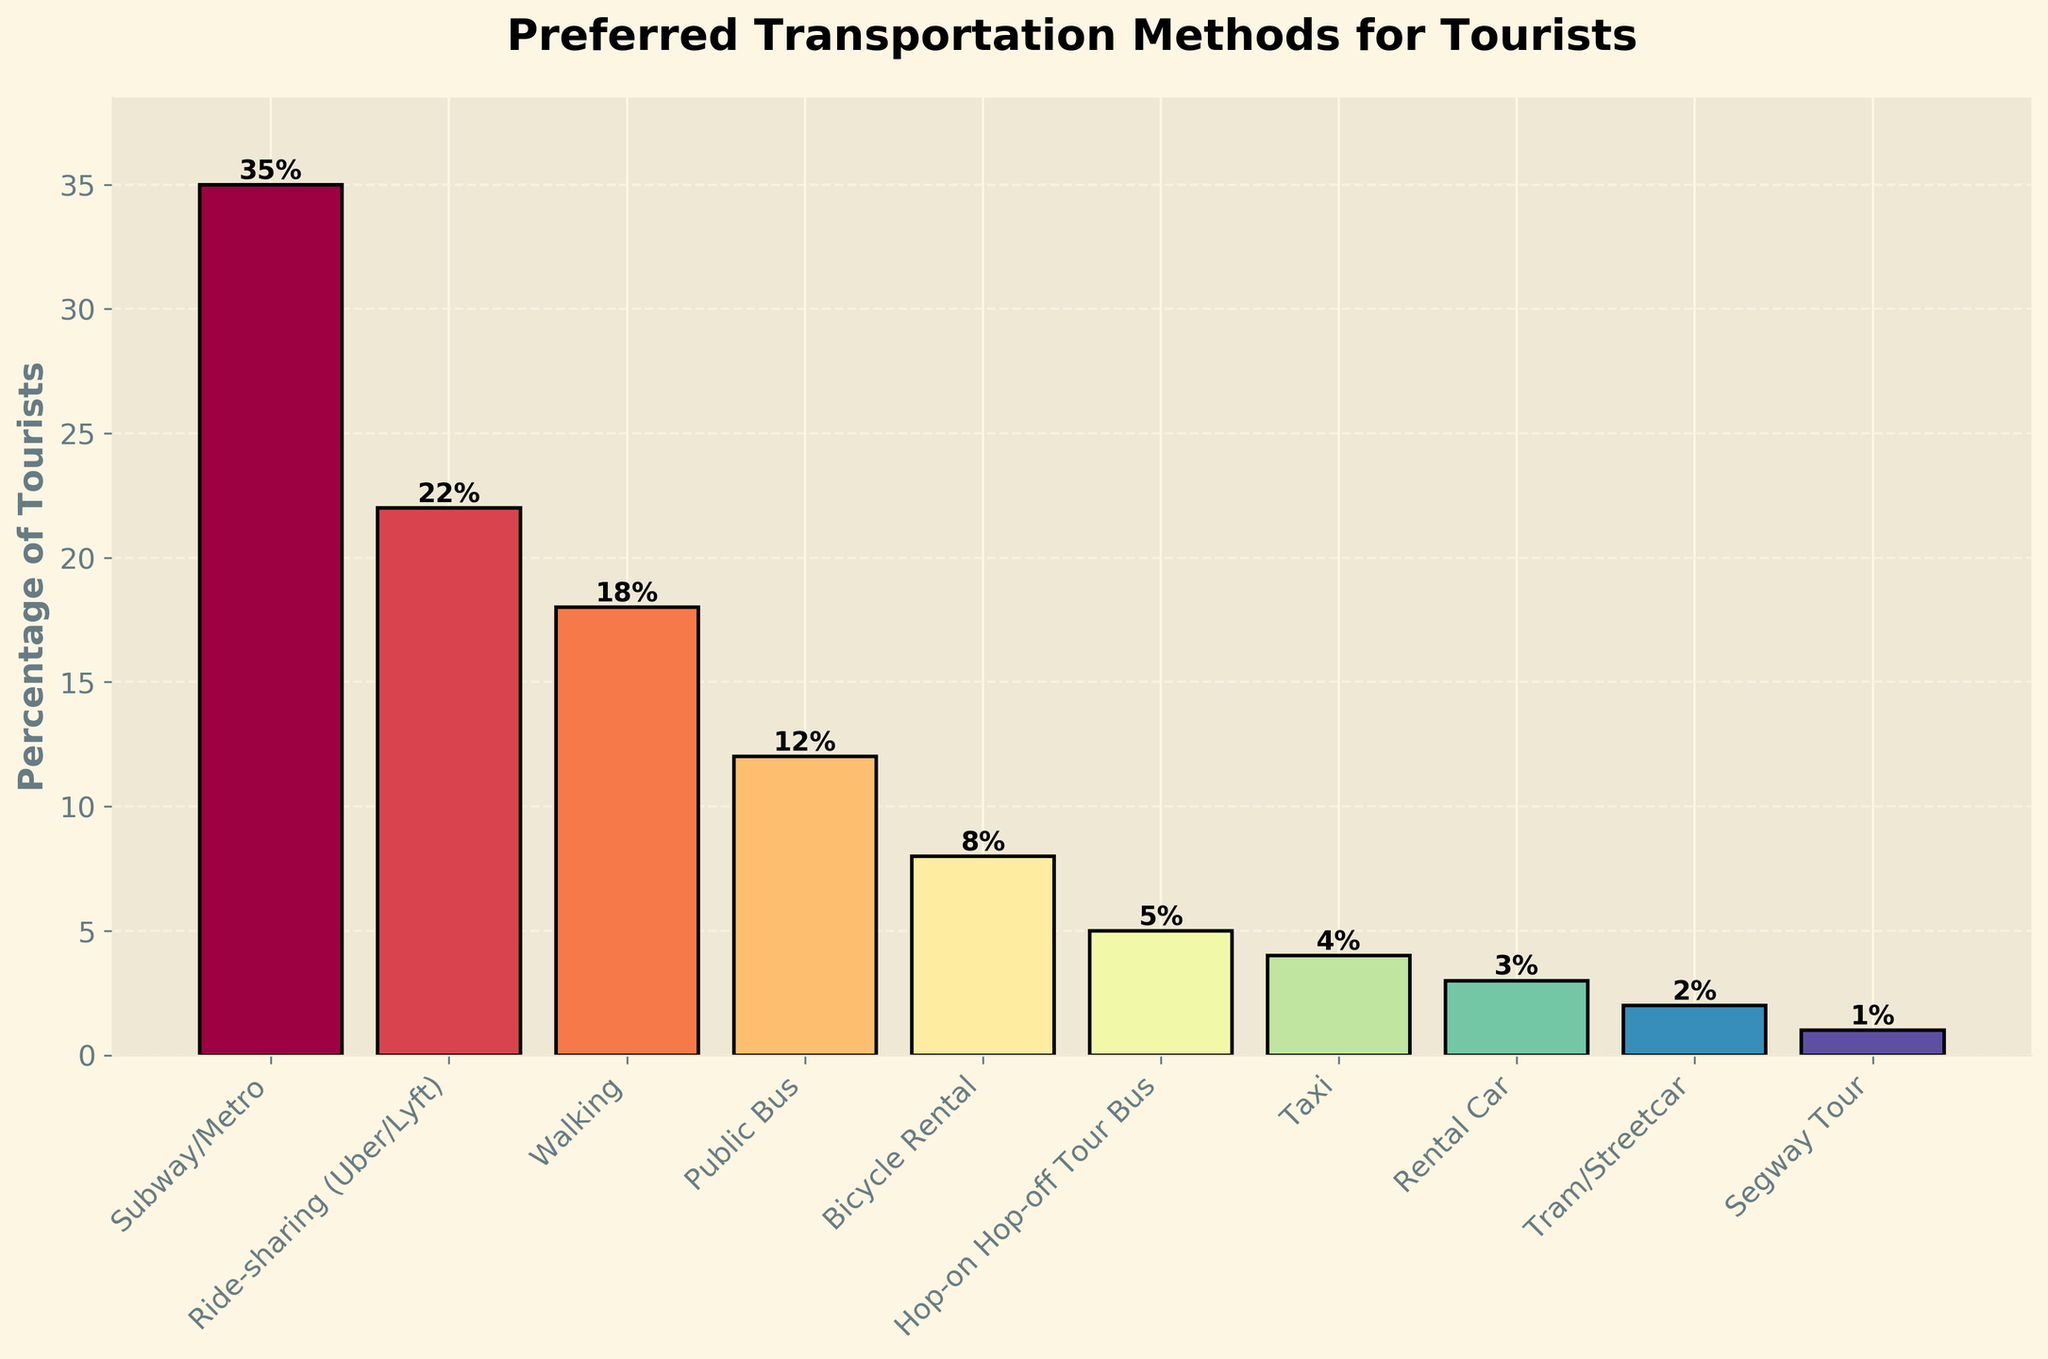Which transportation method is preferred by the highest percentage of tourists? The bar corresponding to "Subway/Metro" is the highest, indicating that 35% of tourists prefer this method.
Answer: Subway/Metro Compare the preferences for "Ride-sharing" and "Public Bus" methods. Which one is more preferred and by how much? "Ride-sharing (Uber/Lyft)" is preferred by 22% of tourists, while "Public Bus" is preferred by 12%. Therefore, "Ride-sharing" is more preferred by 10%.
Answer: Ride-sharing, by 10% How much higher is the percentage of tourists preferring "Walking" compared to those preferring "Bicycle Rental"? "Walking" is preferred by 18% of tourists, whereas "Bicycle Rental" is preferred by 8%, making "Walking" more popular by 10%.
Answer: 10% What is the combined percentage of tourists who prefer the "Tram/Streetcar" and "Segway Tour" methods? The percentage for "Tram/Streetcar" is 2% and for "Segway Tour" it is 1%. Their combined percentage is 2% + 1% = 3%.
Answer: 3% Which transportation method is least preferred by tourists, and what percentage does it represent? The "Segway Tour" has the shortest bar and is labeled with 1%, making it the least preferred method.
Answer: Segway Tour, 1% Compare the preferences for "Hop-on Hop-off Tour Bus" and "Taxi". Which method has a higher percentage and by how much? The "Hop-on Hop-off Tour Bus" is preferred by 5% of tourists, while "Taxi" is preferred by 4%. Therefore, "Hop-on Hop-off Tour Bus" is more preferred by 1%.
Answer: Hop-on Hop-off Tour Bus, by 1% What is the total percentage of tourists who prefer either "Taxi" or "Rental Car"? "Taxi" is preferred by 4% and "Rental Car" by 3%. Summing these gives 4% + 3% = 7%.
Answer: 7% What fraction of tourists prefer "Public Bus" compared to those who prefer "Ride-sharing"? "Public Bus" is preferred by 12% and "Ride-sharing" by 22%. The fraction is 12/22, which simplifies to approximately 0.545.
Answer: ~0.545 Which method has a percentage closest to 20%? "Ride-sharing (Uber/Lyft)" has a percentage of 22%, which is the closest to 20%.
Answer: Ride-sharing (Uber/Lyft) 